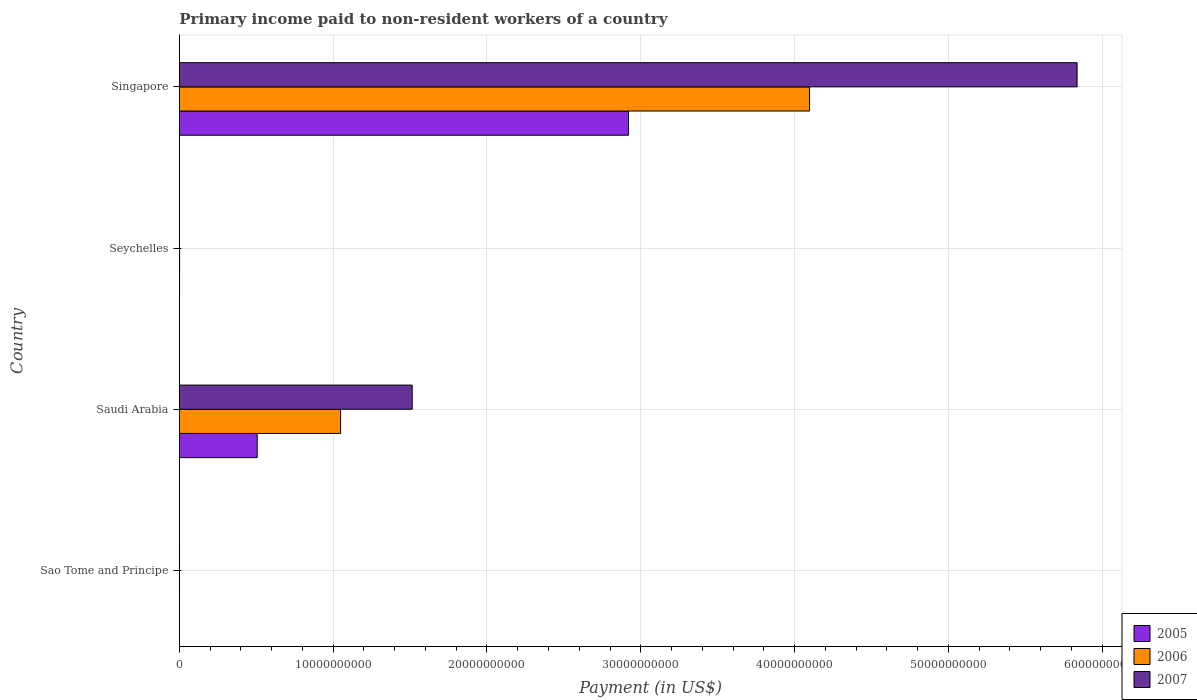How many groups of bars are there?
Ensure brevity in your answer.  4. Are the number of bars on each tick of the Y-axis equal?
Ensure brevity in your answer.  Yes. What is the label of the 3rd group of bars from the top?
Offer a terse response. Saudi Arabia. What is the amount paid to workers in 2005 in Saudi Arabia?
Make the answer very short. 5.06e+09. Across all countries, what is the maximum amount paid to workers in 2007?
Make the answer very short. 5.84e+1. Across all countries, what is the minimum amount paid to workers in 2006?
Keep it short and to the point. 6.15e+06. In which country was the amount paid to workers in 2006 maximum?
Keep it short and to the point. Singapore. In which country was the amount paid to workers in 2005 minimum?
Ensure brevity in your answer.  Sao Tome and Principe. What is the total amount paid to workers in 2007 in the graph?
Offer a terse response. 7.35e+1. What is the difference between the amount paid to workers in 2007 in Sao Tome and Principe and that in Seychelles?
Give a very brief answer. 3.19e+06. What is the difference between the amount paid to workers in 2005 in Singapore and the amount paid to workers in 2007 in Seychelles?
Ensure brevity in your answer.  2.92e+1. What is the average amount paid to workers in 2005 per country?
Provide a succinct answer. 8.57e+09. What is the difference between the amount paid to workers in 2005 and amount paid to workers in 2006 in Seychelles?
Offer a very short reply. -4.60e+05. What is the ratio of the amount paid to workers in 2005 in Saudi Arabia to that in Seychelles?
Your answer should be compact. 515.66. Is the amount paid to workers in 2007 in Saudi Arabia less than that in Singapore?
Give a very brief answer. Yes. What is the difference between the highest and the second highest amount paid to workers in 2007?
Your answer should be very brief. 4.32e+1. What is the difference between the highest and the lowest amount paid to workers in 2006?
Your answer should be compact. 4.10e+1. What does the 2nd bar from the bottom in Sao Tome and Principe represents?
Offer a very short reply. 2006. Is it the case that in every country, the sum of the amount paid to workers in 2005 and amount paid to workers in 2006 is greater than the amount paid to workers in 2007?
Give a very brief answer. Yes. Does the graph contain any zero values?
Provide a short and direct response. No. What is the title of the graph?
Offer a terse response. Primary income paid to non-resident workers of a country. Does "1975" appear as one of the legend labels in the graph?
Make the answer very short. No. What is the label or title of the X-axis?
Make the answer very short. Payment (in US$). What is the Payment (in US$) in 2005 in Sao Tome and Principe?
Provide a succinct answer. 1.97e+06. What is the Payment (in US$) of 2006 in Sao Tome and Principe?
Your answer should be compact. 6.15e+06. What is the Payment (in US$) in 2007 in Sao Tome and Principe?
Your response must be concise. 6.76e+06. What is the Payment (in US$) of 2005 in Saudi Arabia?
Offer a terse response. 5.06e+09. What is the Payment (in US$) in 2006 in Saudi Arabia?
Offer a terse response. 1.05e+1. What is the Payment (in US$) in 2007 in Saudi Arabia?
Your response must be concise. 1.51e+1. What is the Payment (in US$) in 2005 in Seychelles?
Your answer should be very brief. 9.81e+06. What is the Payment (in US$) of 2006 in Seychelles?
Your answer should be compact. 1.03e+07. What is the Payment (in US$) in 2007 in Seychelles?
Provide a succinct answer. 3.58e+06. What is the Payment (in US$) of 2005 in Singapore?
Your response must be concise. 2.92e+1. What is the Payment (in US$) of 2006 in Singapore?
Keep it short and to the point. 4.10e+1. What is the Payment (in US$) of 2007 in Singapore?
Provide a short and direct response. 5.84e+1. Across all countries, what is the maximum Payment (in US$) of 2005?
Your response must be concise. 2.92e+1. Across all countries, what is the maximum Payment (in US$) of 2006?
Your answer should be compact. 4.10e+1. Across all countries, what is the maximum Payment (in US$) in 2007?
Provide a short and direct response. 5.84e+1. Across all countries, what is the minimum Payment (in US$) in 2005?
Make the answer very short. 1.97e+06. Across all countries, what is the minimum Payment (in US$) in 2006?
Ensure brevity in your answer.  6.15e+06. Across all countries, what is the minimum Payment (in US$) of 2007?
Offer a terse response. 3.58e+06. What is the total Payment (in US$) in 2005 in the graph?
Offer a terse response. 3.43e+1. What is the total Payment (in US$) in 2006 in the graph?
Offer a very short reply. 5.15e+1. What is the total Payment (in US$) of 2007 in the graph?
Provide a succinct answer. 7.35e+1. What is the difference between the Payment (in US$) in 2005 in Sao Tome and Principe and that in Saudi Arabia?
Ensure brevity in your answer.  -5.06e+09. What is the difference between the Payment (in US$) in 2006 in Sao Tome and Principe and that in Saudi Arabia?
Offer a very short reply. -1.05e+1. What is the difference between the Payment (in US$) in 2007 in Sao Tome and Principe and that in Saudi Arabia?
Your response must be concise. -1.51e+1. What is the difference between the Payment (in US$) of 2005 in Sao Tome and Principe and that in Seychelles?
Give a very brief answer. -7.84e+06. What is the difference between the Payment (in US$) of 2006 in Sao Tome and Principe and that in Seychelles?
Give a very brief answer. -4.12e+06. What is the difference between the Payment (in US$) of 2007 in Sao Tome and Principe and that in Seychelles?
Make the answer very short. 3.19e+06. What is the difference between the Payment (in US$) in 2005 in Sao Tome and Principe and that in Singapore?
Make the answer very short. -2.92e+1. What is the difference between the Payment (in US$) of 2006 in Sao Tome and Principe and that in Singapore?
Offer a terse response. -4.10e+1. What is the difference between the Payment (in US$) of 2007 in Sao Tome and Principe and that in Singapore?
Your response must be concise. -5.84e+1. What is the difference between the Payment (in US$) in 2005 in Saudi Arabia and that in Seychelles?
Provide a short and direct response. 5.05e+09. What is the difference between the Payment (in US$) of 2006 in Saudi Arabia and that in Seychelles?
Offer a terse response. 1.05e+1. What is the difference between the Payment (in US$) in 2007 in Saudi Arabia and that in Seychelles?
Make the answer very short. 1.51e+1. What is the difference between the Payment (in US$) in 2005 in Saudi Arabia and that in Singapore?
Offer a terse response. -2.41e+1. What is the difference between the Payment (in US$) of 2006 in Saudi Arabia and that in Singapore?
Ensure brevity in your answer.  -3.05e+1. What is the difference between the Payment (in US$) in 2007 in Saudi Arabia and that in Singapore?
Keep it short and to the point. -4.32e+1. What is the difference between the Payment (in US$) of 2005 in Seychelles and that in Singapore?
Keep it short and to the point. -2.92e+1. What is the difference between the Payment (in US$) of 2006 in Seychelles and that in Singapore?
Offer a very short reply. -4.10e+1. What is the difference between the Payment (in US$) in 2007 in Seychelles and that in Singapore?
Provide a short and direct response. -5.84e+1. What is the difference between the Payment (in US$) in 2005 in Sao Tome and Principe and the Payment (in US$) in 2006 in Saudi Arabia?
Give a very brief answer. -1.05e+1. What is the difference between the Payment (in US$) of 2005 in Sao Tome and Principe and the Payment (in US$) of 2007 in Saudi Arabia?
Keep it short and to the point. -1.51e+1. What is the difference between the Payment (in US$) in 2006 in Sao Tome and Principe and the Payment (in US$) in 2007 in Saudi Arabia?
Provide a short and direct response. -1.51e+1. What is the difference between the Payment (in US$) in 2005 in Sao Tome and Principe and the Payment (in US$) in 2006 in Seychelles?
Keep it short and to the point. -8.30e+06. What is the difference between the Payment (in US$) of 2005 in Sao Tome and Principe and the Payment (in US$) of 2007 in Seychelles?
Give a very brief answer. -1.61e+06. What is the difference between the Payment (in US$) in 2006 in Sao Tome and Principe and the Payment (in US$) in 2007 in Seychelles?
Provide a short and direct response. 2.58e+06. What is the difference between the Payment (in US$) in 2005 in Sao Tome and Principe and the Payment (in US$) in 2006 in Singapore?
Provide a succinct answer. -4.10e+1. What is the difference between the Payment (in US$) of 2005 in Sao Tome and Principe and the Payment (in US$) of 2007 in Singapore?
Provide a succinct answer. -5.84e+1. What is the difference between the Payment (in US$) in 2006 in Sao Tome and Principe and the Payment (in US$) in 2007 in Singapore?
Keep it short and to the point. -5.84e+1. What is the difference between the Payment (in US$) of 2005 in Saudi Arabia and the Payment (in US$) of 2006 in Seychelles?
Offer a terse response. 5.05e+09. What is the difference between the Payment (in US$) in 2005 in Saudi Arabia and the Payment (in US$) in 2007 in Seychelles?
Provide a short and direct response. 5.05e+09. What is the difference between the Payment (in US$) of 2006 in Saudi Arabia and the Payment (in US$) of 2007 in Seychelles?
Offer a terse response. 1.05e+1. What is the difference between the Payment (in US$) of 2005 in Saudi Arabia and the Payment (in US$) of 2006 in Singapore?
Offer a very short reply. -3.59e+1. What is the difference between the Payment (in US$) of 2005 in Saudi Arabia and the Payment (in US$) of 2007 in Singapore?
Keep it short and to the point. -5.33e+1. What is the difference between the Payment (in US$) in 2006 in Saudi Arabia and the Payment (in US$) in 2007 in Singapore?
Your answer should be compact. -4.79e+1. What is the difference between the Payment (in US$) of 2005 in Seychelles and the Payment (in US$) of 2006 in Singapore?
Your answer should be very brief. -4.10e+1. What is the difference between the Payment (in US$) of 2005 in Seychelles and the Payment (in US$) of 2007 in Singapore?
Provide a short and direct response. -5.84e+1. What is the difference between the Payment (in US$) in 2006 in Seychelles and the Payment (in US$) in 2007 in Singapore?
Ensure brevity in your answer.  -5.84e+1. What is the average Payment (in US$) in 2005 per country?
Your answer should be very brief. 8.57e+09. What is the average Payment (in US$) in 2006 per country?
Provide a succinct answer. 1.29e+1. What is the average Payment (in US$) in 2007 per country?
Offer a very short reply. 1.84e+1. What is the difference between the Payment (in US$) in 2005 and Payment (in US$) in 2006 in Sao Tome and Principe?
Your response must be concise. -4.18e+06. What is the difference between the Payment (in US$) in 2005 and Payment (in US$) in 2007 in Sao Tome and Principe?
Provide a succinct answer. -4.79e+06. What is the difference between the Payment (in US$) in 2006 and Payment (in US$) in 2007 in Sao Tome and Principe?
Give a very brief answer. -6.11e+05. What is the difference between the Payment (in US$) in 2005 and Payment (in US$) in 2006 in Saudi Arabia?
Offer a terse response. -5.42e+09. What is the difference between the Payment (in US$) of 2005 and Payment (in US$) of 2007 in Saudi Arabia?
Ensure brevity in your answer.  -1.01e+1. What is the difference between the Payment (in US$) in 2006 and Payment (in US$) in 2007 in Saudi Arabia?
Ensure brevity in your answer.  -4.66e+09. What is the difference between the Payment (in US$) in 2005 and Payment (in US$) in 2006 in Seychelles?
Offer a terse response. -4.60e+05. What is the difference between the Payment (in US$) in 2005 and Payment (in US$) in 2007 in Seychelles?
Your answer should be compact. 6.23e+06. What is the difference between the Payment (in US$) in 2006 and Payment (in US$) in 2007 in Seychelles?
Make the answer very short. 6.69e+06. What is the difference between the Payment (in US$) of 2005 and Payment (in US$) of 2006 in Singapore?
Make the answer very short. -1.18e+1. What is the difference between the Payment (in US$) in 2005 and Payment (in US$) in 2007 in Singapore?
Offer a terse response. -2.92e+1. What is the difference between the Payment (in US$) of 2006 and Payment (in US$) of 2007 in Singapore?
Give a very brief answer. -1.74e+1. What is the ratio of the Payment (in US$) in 2006 in Sao Tome and Principe to that in Saudi Arabia?
Give a very brief answer. 0. What is the ratio of the Payment (in US$) in 2005 in Sao Tome and Principe to that in Seychelles?
Offer a very short reply. 0.2. What is the ratio of the Payment (in US$) of 2006 in Sao Tome and Principe to that in Seychelles?
Your response must be concise. 0.6. What is the ratio of the Payment (in US$) of 2007 in Sao Tome and Principe to that in Seychelles?
Your response must be concise. 1.89. What is the ratio of the Payment (in US$) in 2006 in Sao Tome and Principe to that in Singapore?
Your answer should be very brief. 0. What is the ratio of the Payment (in US$) of 2007 in Sao Tome and Principe to that in Singapore?
Offer a very short reply. 0. What is the ratio of the Payment (in US$) of 2005 in Saudi Arabia to that in Seychelles?
Offer a very short reply. 515.66. What is the ratio of the Payment (in US$) of 2006 in Saudi Arabia to that in Seychelles?
Give a very brief answer. 1020.73. What is the ratio of the Payment (in US$) in 2007 in Saudi Arabia to that in Seychelles?
Make the answer very short. 4233.5. What is the ratio of the Payment (in US$) in 2005 in Saudi Arabia to that in Singapore?
Provide a succinct answer. 0.17. What is the ratio of the Payment (in US$) of 2006 in Saudi Arabia to that in Singapore?
Give a very brief answer. 0.26. What is the ratio of the Payment (in US$) in 2007 in Saudi Arabia to that in Singapore?
Your answer should be compact. 0.26. What is the ratio of the Payment (in US$) of 2006 in Seychelles to that in Singapore?
Offer a very short reply. 0. What is the ratio of the Payment (in US$) in 2007 in Seychelles to that in Singapore?
Your response must be concise. 0. What is the difference between the highest and the second highest Payment (in US$) in 2005?
Provide a short and direct response. 2.41e+1. What is the difference between the highest and the second highest Payment (in US$) in 2006?
Keep it short and to the point. 3.05e+1. What is the difference between the highest and the second highest Payment (in US$) in 2007?
Provide a short and direct response. 4.32e+1. What is the difference between the highest and the lowest Payment (in US$) of 2005?
Your response must be concise. 2.92e+1. What is the difference between the highest and the lowest Payment (in US$) of 2006?
Offer a very short reply. 4.10e+1. What is the difference between the highest and the lowest Payment (in US$) in 2007?
Your answer should be compact. 5.84e+1. 